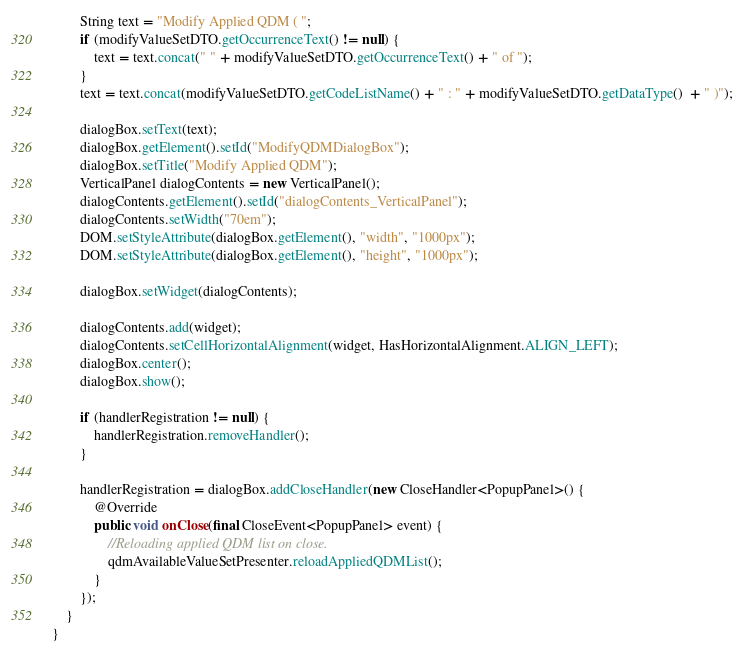<code> <loc_0><loc_0><loc_500><loc_500><_Java_>		String text = "Modify Applied QDM ( ";
		if (modifyValueSetDTO.getOccurrenceText() != null) {
			text = text.concat(" " + modifyValueSetDTO.getOccurrenceText() + " of ");
		}
		text = text.concat(modifyValueSetDTO.getCodeListName() + " : " + modifyValueSetDTO.getDataType()  + " )");
		
		dialogBox.setText(text);
		dialogBox.getElement().setId("ModifyQDMDialogBox");
		dialogBox.setTitle("Modify Applied QDM");
		VerticalPanel dialogContents = new VerticalPanel();
		dialogContents.getElement().setId("dialogContents_VerticalPanel");
		dialogContents.setWidth("70em");
		DOM.setStyleAttribute(dialogBox.getElement(), "width", "1000px");
		DOM.setStyleAttribute(dialogBox.getElement(), "height", "1000px");
		
		dialogBox.setWidget(dialogContents);
		
		dialogContents.add(widget);
		dialogContents.setCellHorizontalAlignment(widget, HasHorizontalAlignment.ALIGN_LEFT);
		dialogBox.center();
		dialogBox.show();
		
		if (handlerRegistration != null) {
			handlerRegistration.removeHandler();
		}
		
		handlerRegistration = dialogBox.addCloseHandler(new CloseHandler<PopupPanel>() {
			@Override
			public void onClose(final CloseEvent<PopupPanel> event) {
				//Reloading applied QDM list on close.
				qdmAvailableValueSetPresenter.reloadAppliedQDMList();
			}
		});
	}
}
</code> 